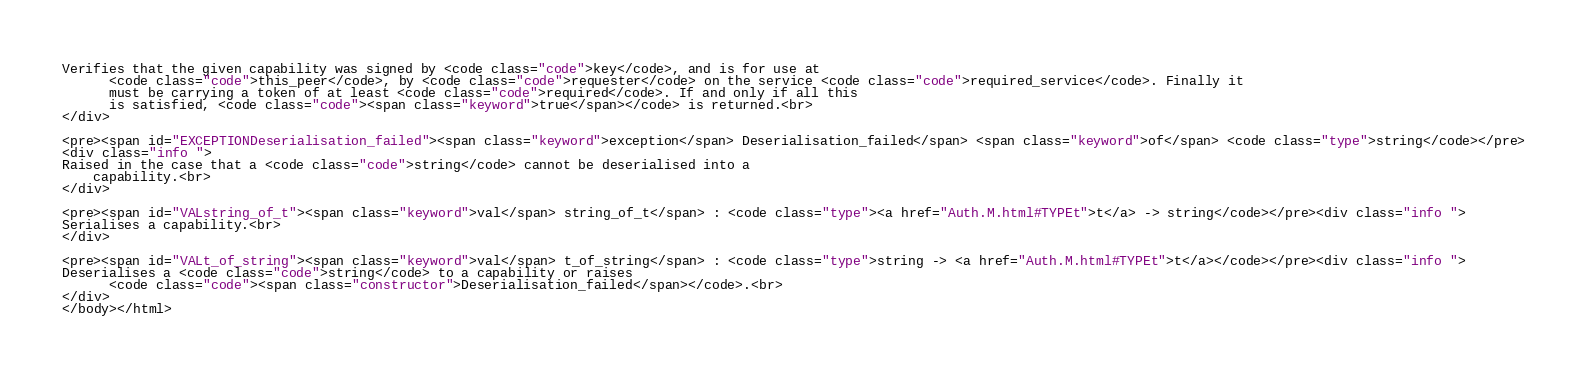Convert code to text. <code><loc_0><loc_0><loc_500><loc_500><_HTML_>Verifies that the given capability was signed by <code class="code">key</code>, and is for use at
      <code class="code">this_peer</code>, by <code class="code">requester</code> on the service <code class="code">required_service</code>. Finally it
      must be carrying a token of at least <code class="code">required</code>. If and only if all this
      is satisfied, <code class="code"><span class="keyword">true</span></code> is returned.<br>
</div>

<pre><span id="EXCEPTIONDeserialisation_failed"><span class="keyword">exception</span> Deserialisation_failed</span> <span class="keyword">of</span> <code class="type">string</code></pre>
<div class="info ">
Raised in the case that a <code class="code">string</code> cannot be deserialised into a
    capability.<br>
</div>

<pre><span id="VALstring_of_t"><span class="keyword">val</span> string_of_t</span> : <code class="type"><a href="Auth.M.html#TYPEt">t</a> -> string</code></pre><div class="info ">
Serialises a capability.<br>
</div>

<pre><span id="VALt_of_string"><span class="keyword">val</span> t_of_string</span> : <code class="type">string -> <a href="Auth.M.html#TYPEt">t</a></code></pre><div class="info ">
Deserialises a <code class="code">string</code> to a capability or raises
      <code class="code"><span class="constructor">Deserialisation_failed</span></code>.<br>
</div>
</body></html></code> 